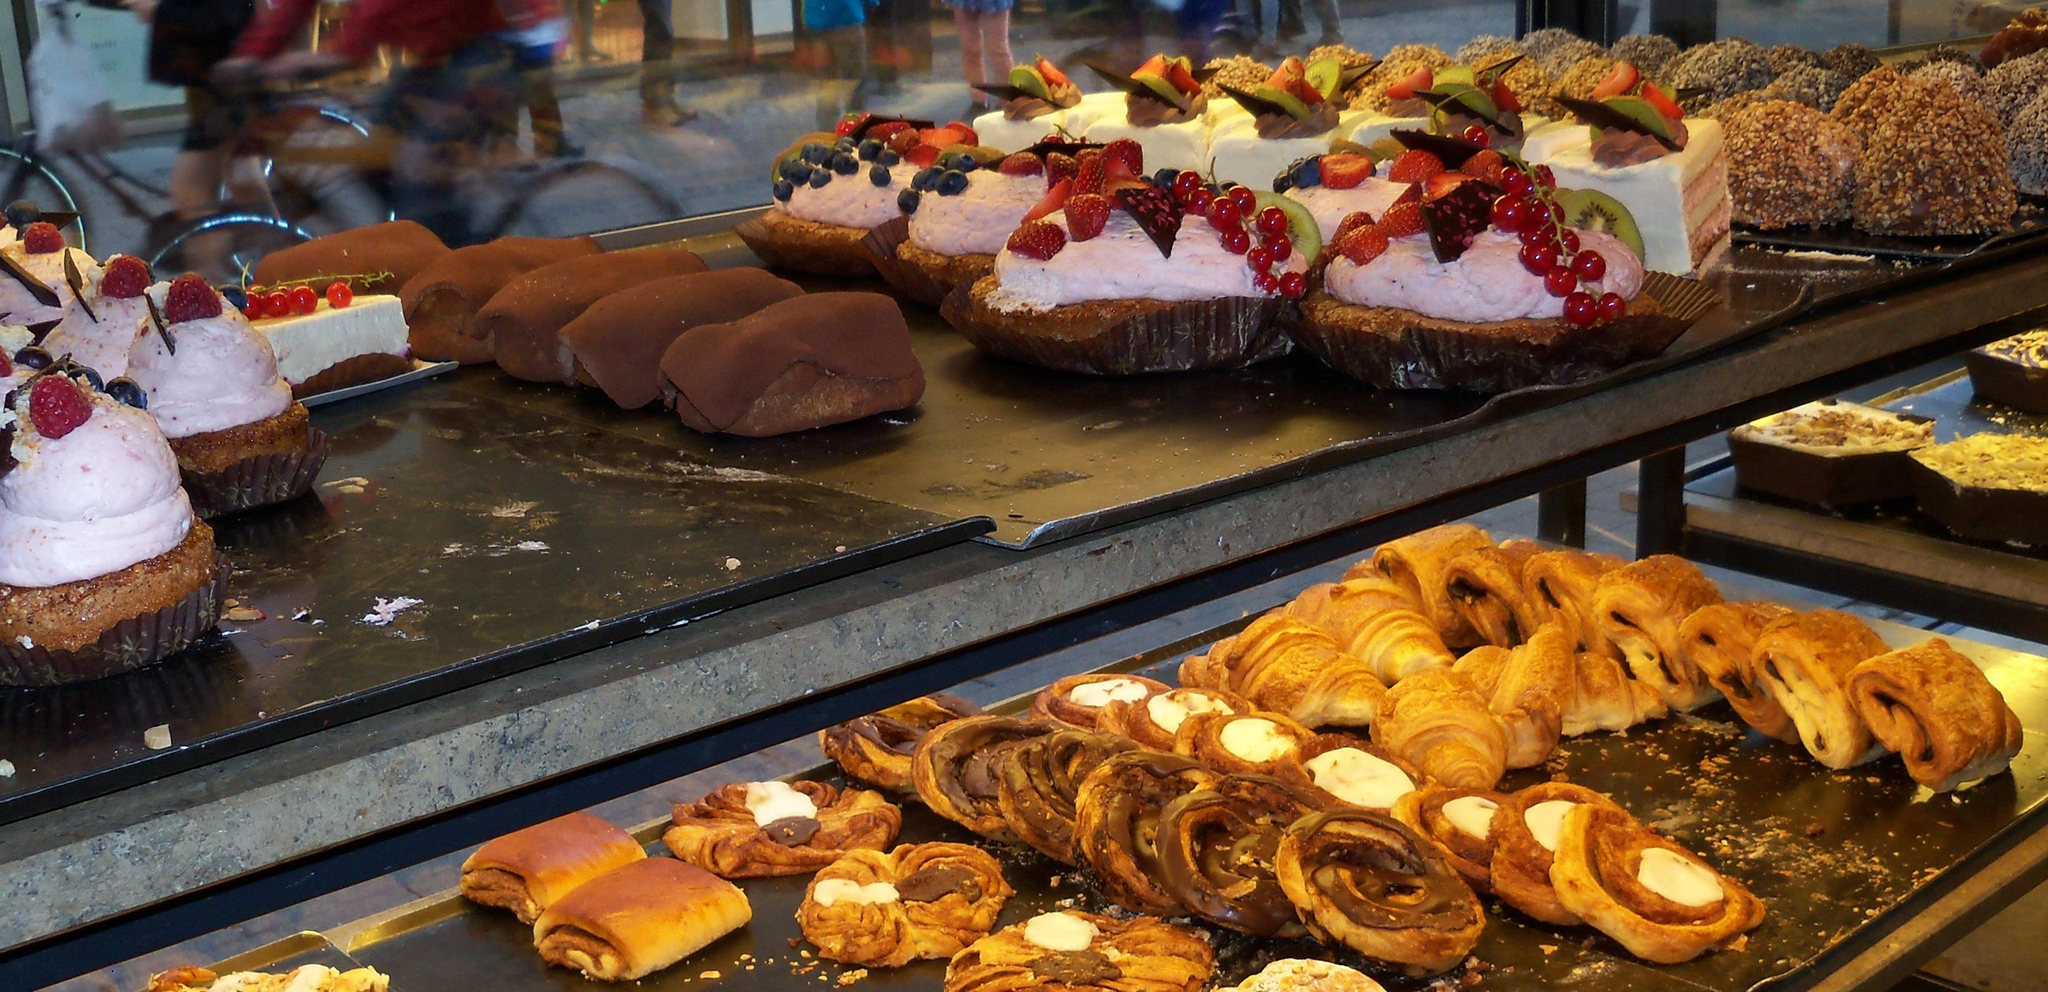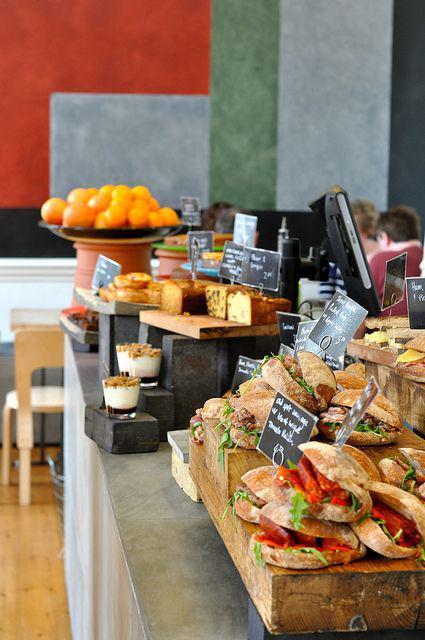The first image is the image on the left, the second image is the image on the right. Assess this claim about the two images: "The left image shows rows of bakery items on display shelves, and includes brown-frosted log shapesnext to white frosted treats garnished with red berries.". Correct or not? Answer yes or no. Yes. 